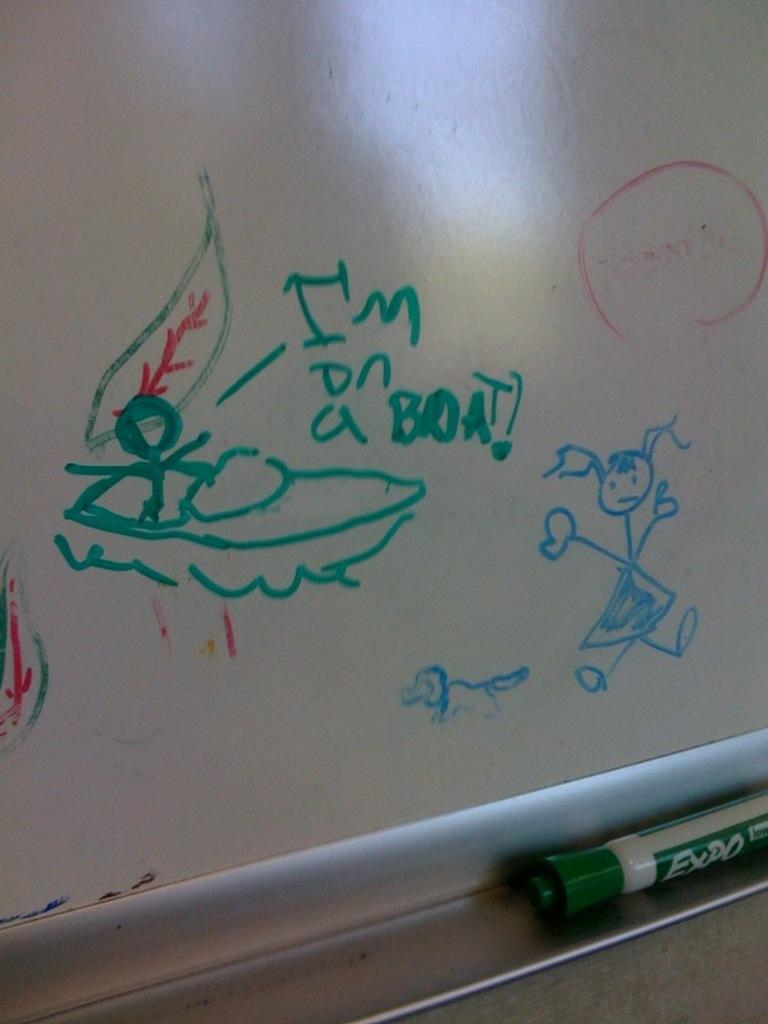<image>
Write a terse but informative summary of the picture. A white board has stick people drawn on it and says "I'm on a boat". 